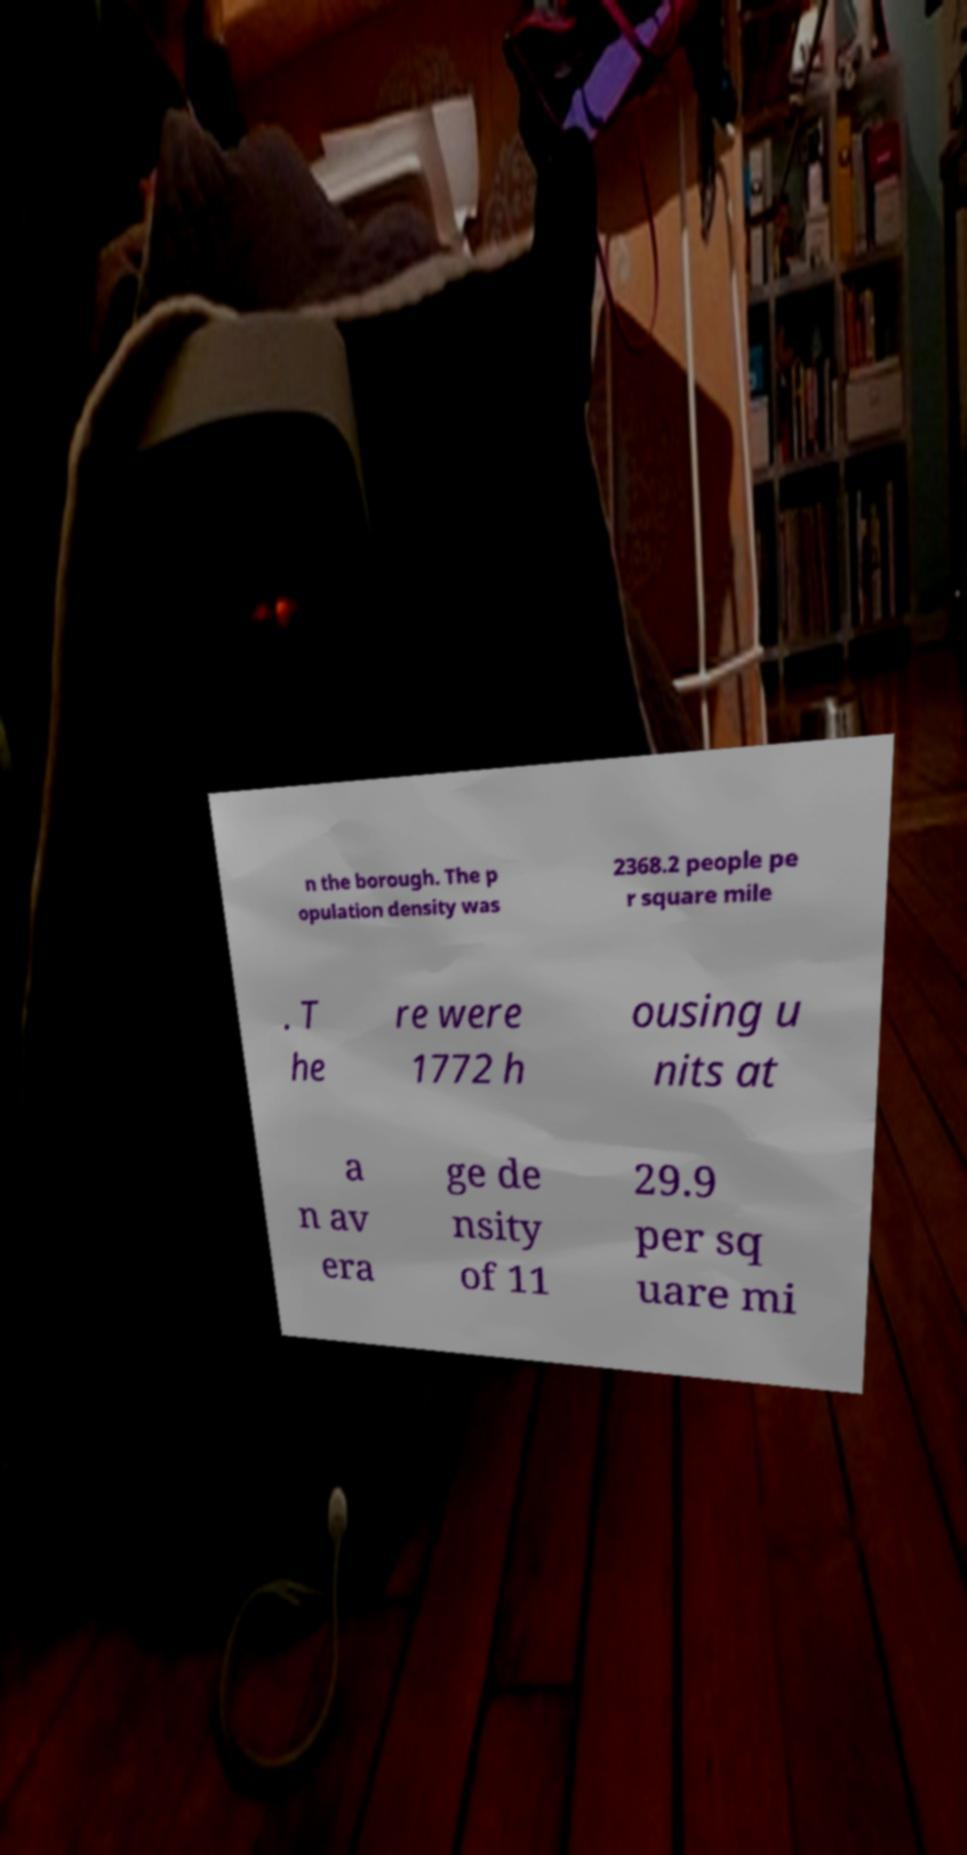Could you assist in decoding the text presented in this image and type it out clearly? n the borough. The p opulation density was 2368.2 people pe r square mile . T he re were 1772 h ousing u nits at a n av era ge de nsity of 11 29.9 per sq uare mi 